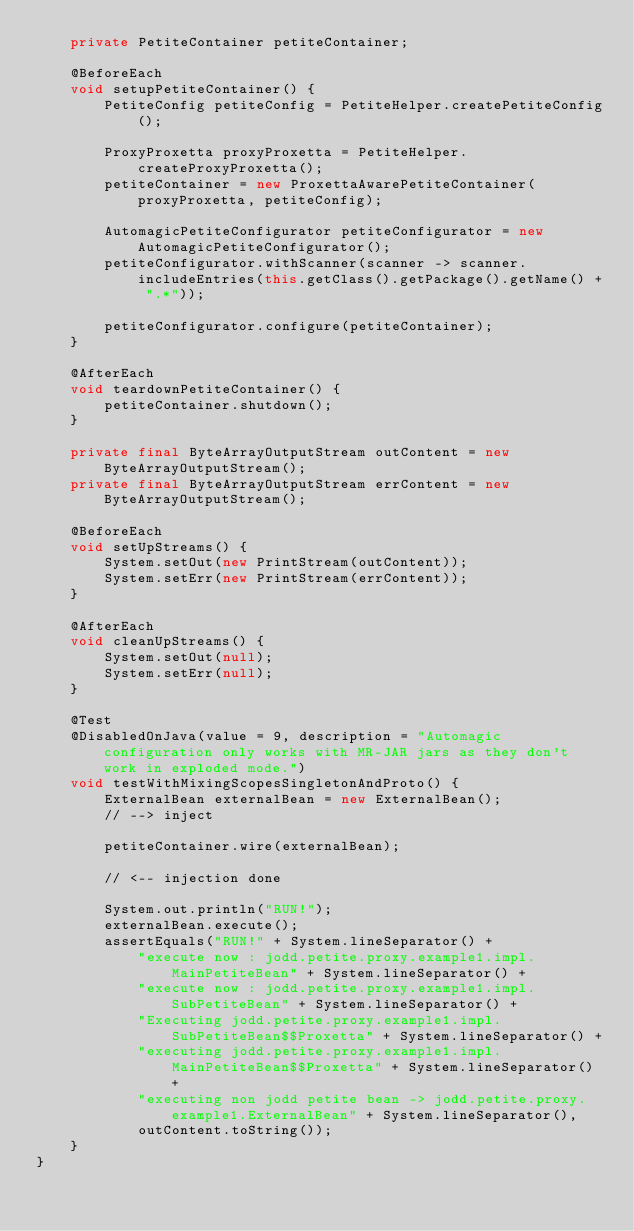<code> <loc_0><loc_0><loc_500><loc_500><_Java_>	private PetiteContainer petiteContainer;

	@BeforeEach
	void setupPetiteContainer() {
		PetiteConfig petiteConfig = PetiteHelper.createPetiteConfig();

		ProxyProxetta proxyProxetta = PetiteHelper.createProxyProxetta();
		petiteContainer = new ProxettaAwarePetiteContainer(proxyProxetta, petiteConfig);

		AutomagicPetiteConfigurator petiteConfigurator = new AutomagicPetiteConfigurator();
		petiteConfigurator.withScanner(scanner -> scanner.includeEntries(this.getClass().getPackage().getName() + ".*"));

		petiteConfigurator.configure(petiteContainer);
	}

	@AfterEach
	void teardownPetiteContainer() {
		petiteContainer.shutdown();
	}

	private final ByteArrayOutputStream outContent = new ByteArrayOutputStream();
	private final ByteArrayOutputStream errContent = new ByteArrayOutputStream();

	@BeforeEach
	void setUpStreams() {
		System.setOut(new PrintStream(outContent));
		System.setErr(new PrintStream(errContent));
	}

	@AfterEach
	void cleanUpStreams() {
		System.setOut(null);
		System.setErr(null);
	}

	@Test
	@DisabledOnJava(value = 9, description = "Automagic configuration only works with MR-JAR jars as they don't work in exploded mode.")
	void testWithMixingScopesSingletonAndProto() {
		ExternalBean externalBean = new ExternalBean();
		// --> inject

		petiteContainer.wire(externalBean);

		// <-- injection done

		System.out.println("RUN!");
		externalBean.execute();
		assertEquals("RUN!" + System.lineSeparator() +
			"execute now : jodd.petite.proxy.example1.impl.MainPetiteBean" + System.lineSeparator() +
			"execute now : jodd.petite.proxy.example1.impl.SubPetiteBean" + System.lineSeparator() +
			"Executing jodd.petite.proxy.example1.impl.SubPetiteBean$$Proxetta" + System.lineSeparator() +
			"executing jodd.petite.proxy.example1.impl.MainPetiteBean$$Proxetta" + System.lineSeparator() +
			"executing non jodd petite bean -> jodd.petite.proxy.example1.ExternalBean" + System.lineSeparator(),
			outContent.toString());
	}
}
</code> 